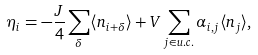Convert formula to latex. <formula><loc_0><loc_0><loc_500><loc_500>\eta _ { i } = - \frac { J } { 4 } \sum _ { \delta } \langle n _ { i + \delta } \rangle + V \sum _ { j \in u . c . } \alpha _ { i , j } \langle n _ { j } \rangle ,</formula> 